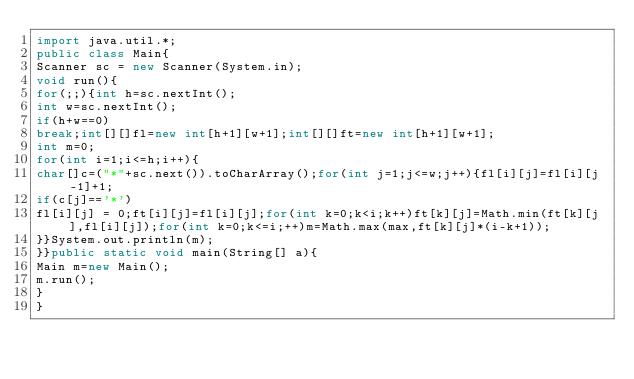Convert code to text. <code><loc_0><loc_0><loc_500><loc_500><_Java_>import java.util.*;
public class Main{
Scanner sc = new Scanner(System.in);
void run(){
for(;;){int h=sc.nextInt();
int w=sc.nextInt();
if(h+w==0)
break;int[][]fl=new int[h+1][w+1];int[][]ft=new int[h+1][w+1];
int m=0;
for(int i=1;i<=h;i++){
char[]c=("*"+sc.next()).toCharArray();for(int j=1;j<=w;j++){fl[i][j]=fl[i][j-1]+1;
if(c[j]=='*')
fl[i][j] = 0;ft[i][j]=fl[i][j];for(int k=0;k<i;k++)ft[k][j]=Math.min(ft[k][j],fl[i][j]);for(int k=0;k<=i;++)m=Math.max(max,ft[k][j]*(i-k+1));
}}System.out.println(m);
}}public static void main(String[] a){
Main m=new Main();
m.run();
}
}</code> 